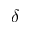Convert formula to latex. <formula><loc_0><loc_0><loc_500><loc_500>\delta</formula> 